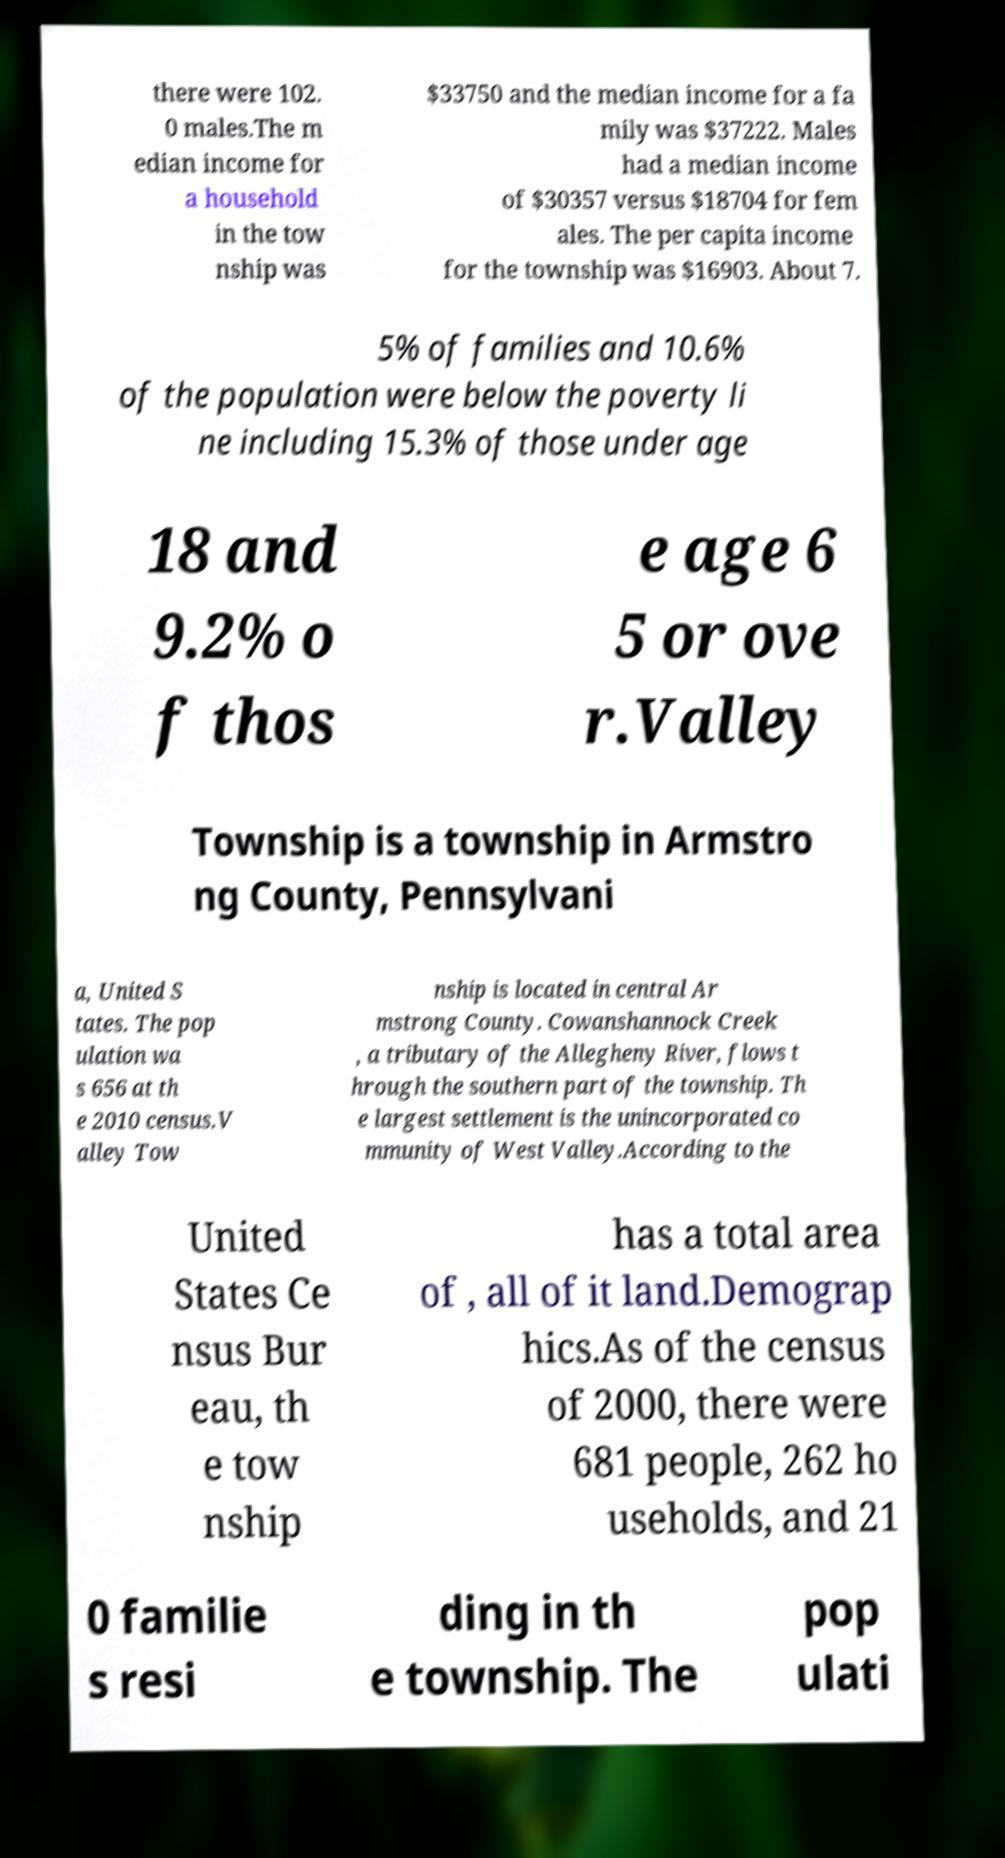Please identify and transcribe the text found in this image. there were 102. 0 males.The m edian income for a household in the tow nship was $33750 and the median income for a fa mily was $37222. Males had a median income of $30357 versus $18704 for fem ales. The per capita income for the township was $16903. About 7. 5% of families and 10.6% of the population were below the poverty li ne including 15.3% of those under age 18 and 9.2% o f thos e age 6 5 or ove r.Valley Township is a township in Armstro ng County, Pennsylvani a, United S tates. The pop ulation wa s 656 at th e 2010 census.V alley Tow nship is located in central Ar mstrong County. Cowanshannock Creek , a tributary of the Allegheny River, flows t hrough the southern part of the township. Th e largest settlement is the unincorporated co mmunity of West Valley.According to the United States Ce nsus Bur eau, th e tow nship has a total area of , all of it land.Demograp hics.As of the census of 2000, there were 681 people, 262 ho useholds, and 21 0 familie s resi ding in th e township. The pop ulati 